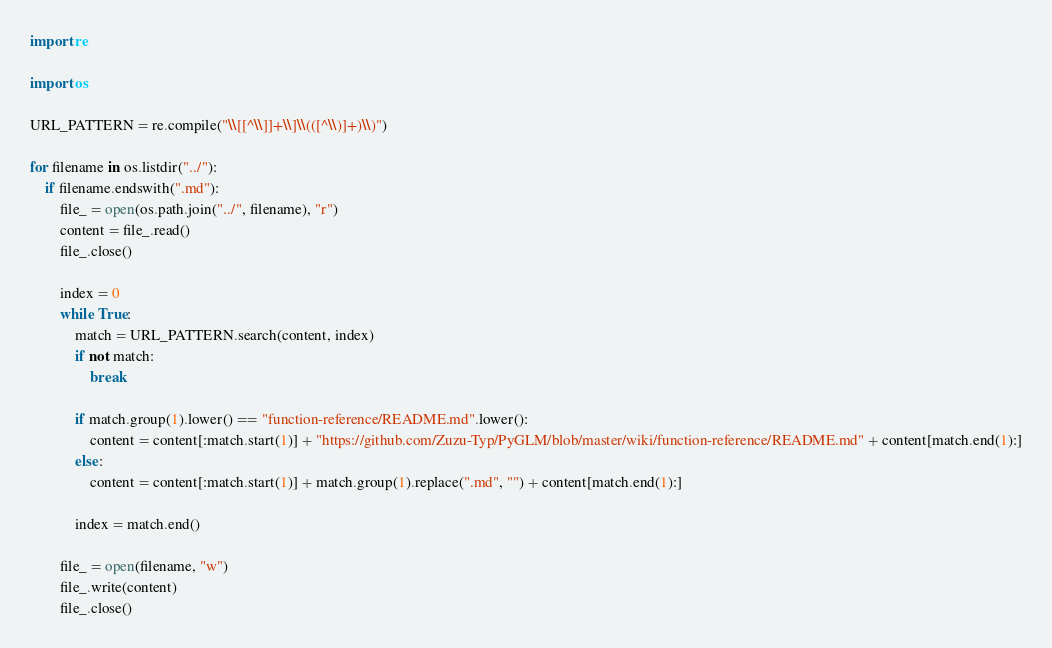Convert code to text. <code><loc_0><loc_0><loc_500><loc_500><_Python_>import re

import os

URL_PATTERN = re.compile("\\[[^\\]]+\\]\\(([^\\)]+)\\)")

for filename in os.listdir("../"):
    if filename.endswith(".md"):
        file_ = open(os.path.join("../", filename), "r")
        content = file_.read()
        file_.close()
        
        index = 0
        while True:
            match = URL_PATTERN.search(content, index)
            if not match:
                break
            
            if match.group(1).lower() == "function-reference/README.md".lower():
                content = content[:match.start(1)] + "https://github.com/Zuzu-Typ/PyGLM/blob/master/wiki/function-reference/README.md" + content[match.end(1):]
            else:
                content = content[:match.start(1)] + match.group(1).replace(".md", "") + content[match.end(1):]
            
            index = match.end()
            
        file_ = open(filename, "w")
        file_.write(content)
        file_.close()</code> 